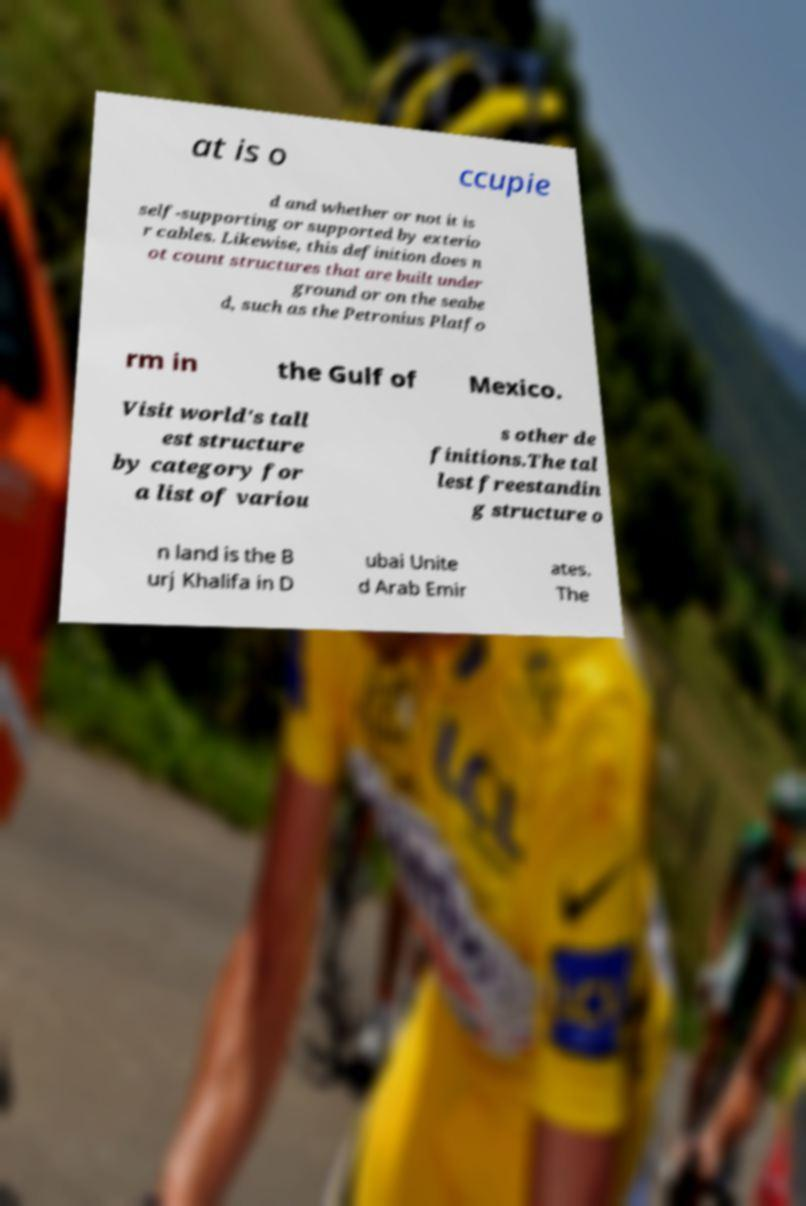There's text embedded in this image that I need extracted. Can you transcribe it verbatim? at is o ccupie d and whether or not it is self-supporting or supported by exterio r cables. Likewise, this definition does n ot count structures that are built under ground or on the seabe d, such as the Petronius Platfo rm in the Gulf of Mexico. Visit world's tall est structure by category for a list of variou s other de finitions.The tal lest freestandin g structure o n land is the B urj Khalifa in D ubai Unite d Arab Emir ates. The 